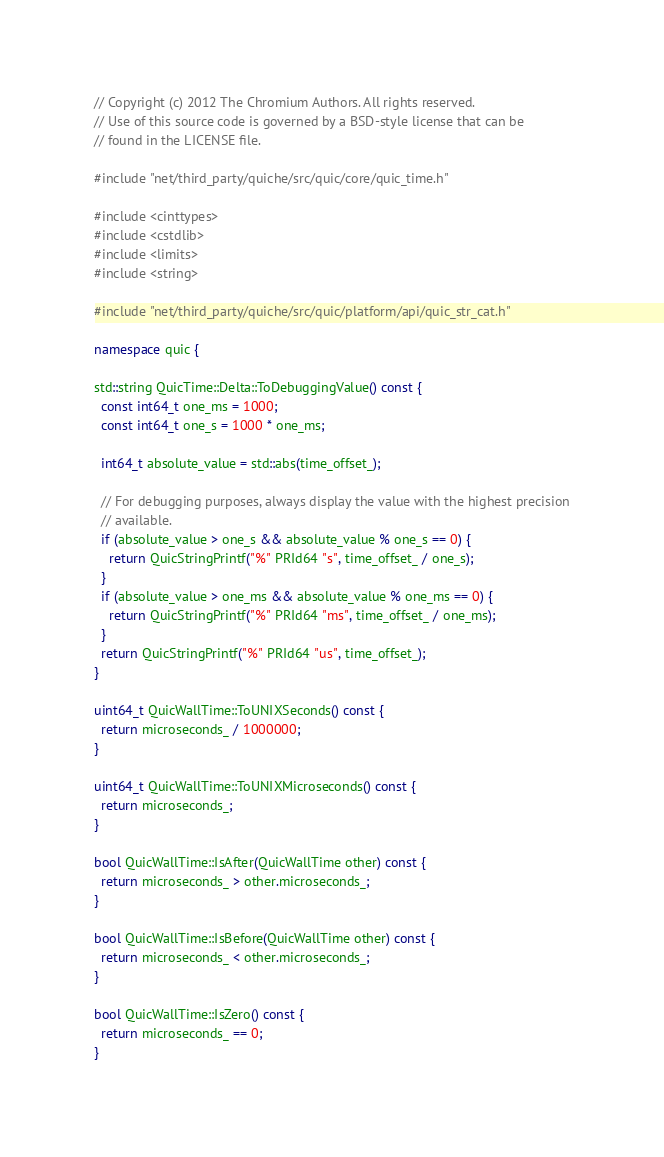Convert code to text. <code><loc_0><loc_0><loc_500><loc_500><_C++_>// Copyright (c) 2012 The Chromium Authors. All rights reserved.
// Use of this source code is governed by a BSD-style license that can be
// found in the LICENSE file.

#include "net/third_party/quiche/src/quic/core/quic_time.h"

#include <cinttypes>
#include <cstdlib>
#include <limits>
#include <string>

#include "net/third_party/quiche/src/quic/platform/api/quic_str_cat.h"

namespace quic {

std::string QuicTime::Delta::ToDebuggingValue() const {
  const int64_t one_ms = 1000;
  const int64_t one_s = 1000 * one_ms;

  int64_t absolute_value = std::abs(time_offset_);

  // For debugging purposes, always display the value with the highest precision
  // available.
  if (absolute_value > one_s && absolute_value % one_s == 0) {
    return QuicStringPrintf("%" PRId64 "s", time_offset_ / one_s);
  }
  if (absolute_value > one_ms && absolute_value % one_ms == 0) {
    return QuicStringPrintf("%" PRId64 "ms", time_offset_ / one_ms);
  }
  return QuicStringPrintf("%" PRId64 "us", time_offset_);
}

uint64_t QuicWallTime::ToUNIXSeconds() const {
  return microseconds_ / 1000000;
}

uint64_t QuicWallTime::ToUNIXMicroseconds() const {
  return microseconds_;
}

bool QuicWallTime::IsAfter(QuicWallTime other) const {
  return microseconds_ > other.microseconds_;
}

bool QuicWallTime::IsBefore(QuicWallTime other) const {
  return microseconds_ < other.microseconds_;
}

bool QuicWallTime::IsZero() const {
  return microseconds_ == 0;
}
</code> 